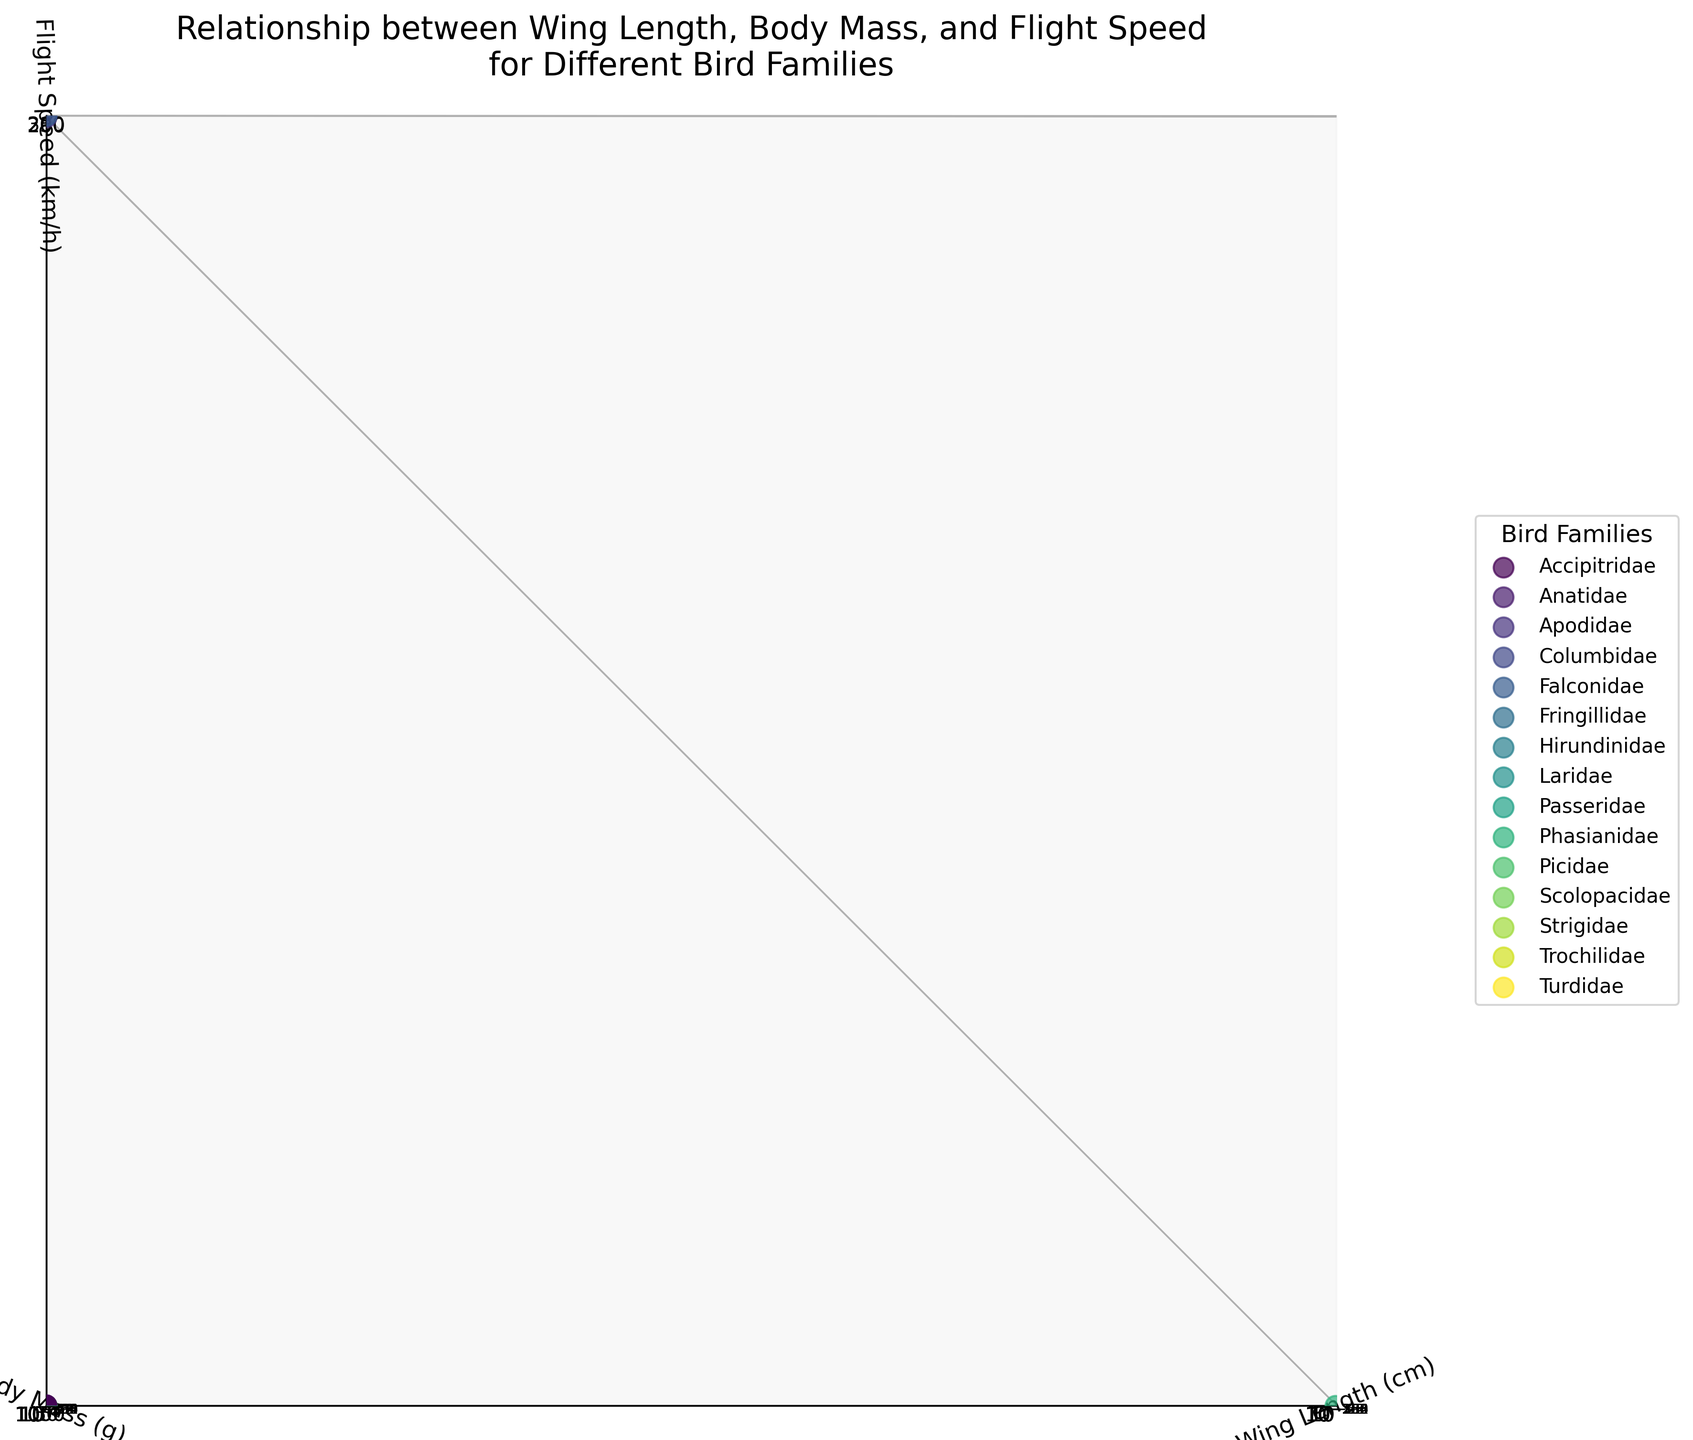How many bird families are represented in the plot? First, look at the legend to see the different colors representing each bird family. Count the number of unique labels in the legend.
Answer: 10 Which bird species has the highest flight speed? Find the point at the highest position along the z-axis labeled "Flight Speed (km/h)." The legend will help identify the associated bird family and species.
Answer: Peregrine Falcon Compare the wing lengths of the Golden Eagle and the Rock Pigeon. Which one has longer wings? Locate the Golden Eagle and Rock Pigeon on the plot using the legend and their positions on the x-axis labeled "Wing Length (cm)." Identify which has a higher x-axis value.
Answer: Golden Eagle Which bird family has the species with the smallest body mass? Check the points closest to the origin on the y-axis labeled "Body Mass (g)" and use the legend to identify the family.
Answer: Trochilidae What is the flight speed of the Canada Goose? Find the Canada Goose on the plot using the legend and check its position on the z-axis labeled "Flight Speed (km/h)."
Answer: 70 km/h Which two bird species have the closest body mass, and what are their masses? Compare positions on the y-axis labeled "Body Mass (g)" for each species to find the smallest difference.
Answer: American Robin and Sandpiper, both around 50 g Are there any bird species with a similar flight speed but different body masses? Look for points aligned along the same z-axis value but differing y-axis positions. Use the legend to identify the species.
Answer: Mallard and Great Horned Owl What are the axes labels, and what scaling is used for each? Observe the labels and their scales: the x-axis represents 'Wing Length (cm)', y-axis represents 'Body Mass (g)', and z-axis represents 'Flight Speed (km/h).' Check for log and linear scales noted in the labels.
Answer: Wing Length (cm) - log scale, Body Mass (g) - log scale, Flight Speed (km/h) - linear scale Which bird has the smallest wings and what is its wing length? Locate the point closest to the origin on the x-axis labeled "Wing Length (cm)." Use the legend to identify the bird species.
Answer: Ruby-throated Hummingbird, 4.1 cm 